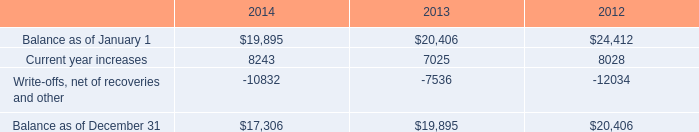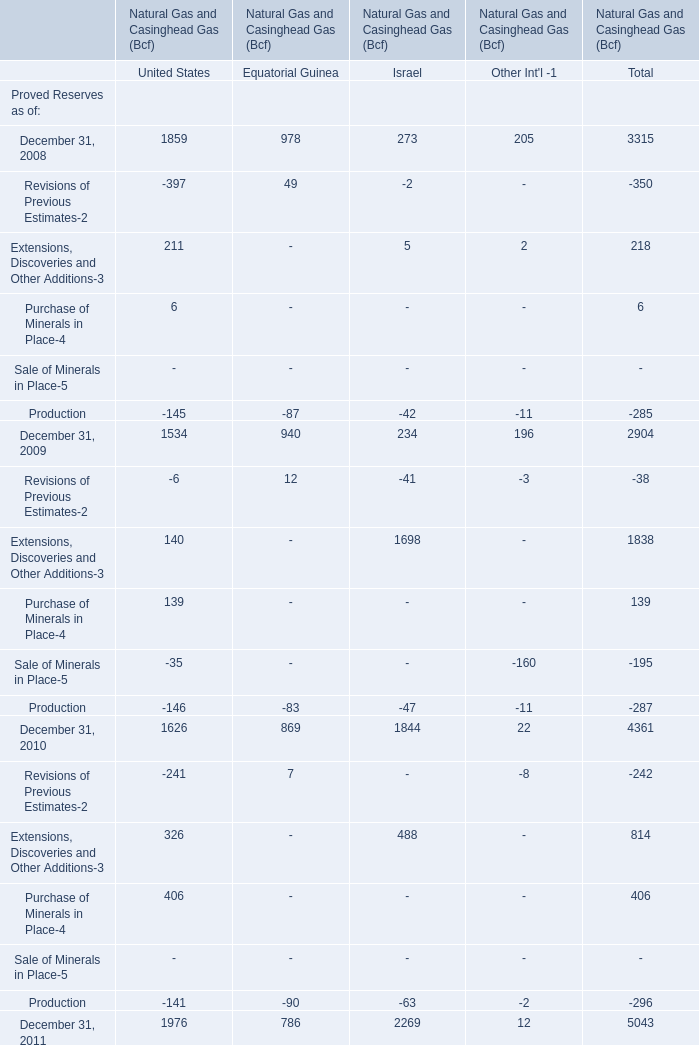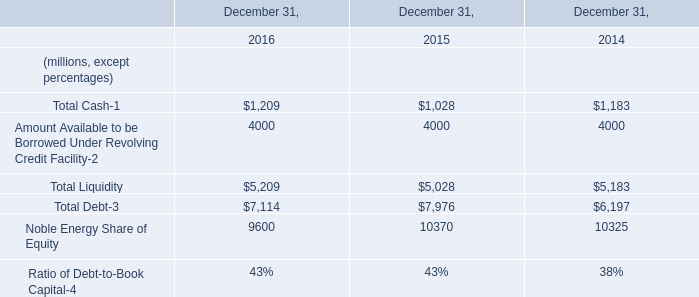What is the sum of Balance as of December 31 of 2013, and Noble Energy Share of Equity of December 31, 2015 ? 
Computations: (19895.0 + 10370.0)
Answer: 30265.0. 